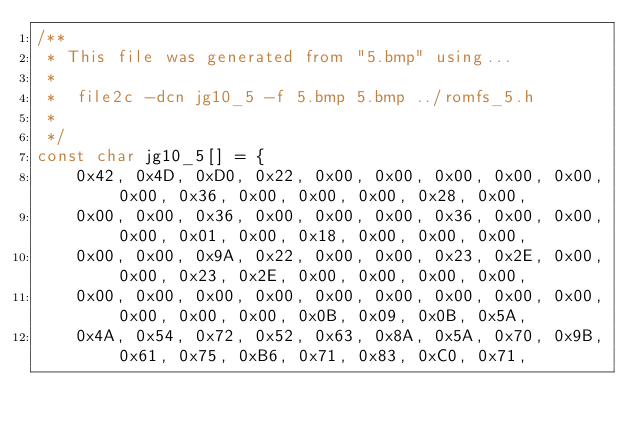<code> <loc_0><loc_0><loc_500><loc_500><_C_>/**
 * This file was generated from "5.bmp" using...
 *
 *	file2c -dcn jg10_5 -f 5.bmp 5.bmp ../romfs_5.h
 *
 */
const char jg10_5[] = {
	0x42, 0x4D, 0xD0, 0x22, 0x00, 0x00, 0x00, 0x00, 0x00, 0x00, 0x36, 0x00, 0x00, 0x00, 0x28, 0x00,
	0x00, 0x00, 0x36, 0x00, 0x00, 0x00, 0x36, 0x00, 0x00, 0x00, 0x01, 0x00, 0x18, 0x00, 0x00, 0x00,
	0x00, 0x00, 0x9A, 0x22, 0x00, 0x00, 0x23, 0x2E, 0x00, 0x00, 0x23, 0x2E, 0x00, 0x00, 0x00, 0x00,
	0x00, 0x00, 0x00, 0x00, 0x00, 0x00, 0x00, 0x00, 0x00, 0x00, 0x00, 0x00, 0x0B, 0x09, 0x0B, 0x5A,
	0x4A, 0x54, 0x72, 0x52, 0x63, 0x8A, 0x5A, 0x70, 0x9B, 0x61, 0x75, 0xB6, 0x71, 0x83, 0xC0, 0x71,</code> 